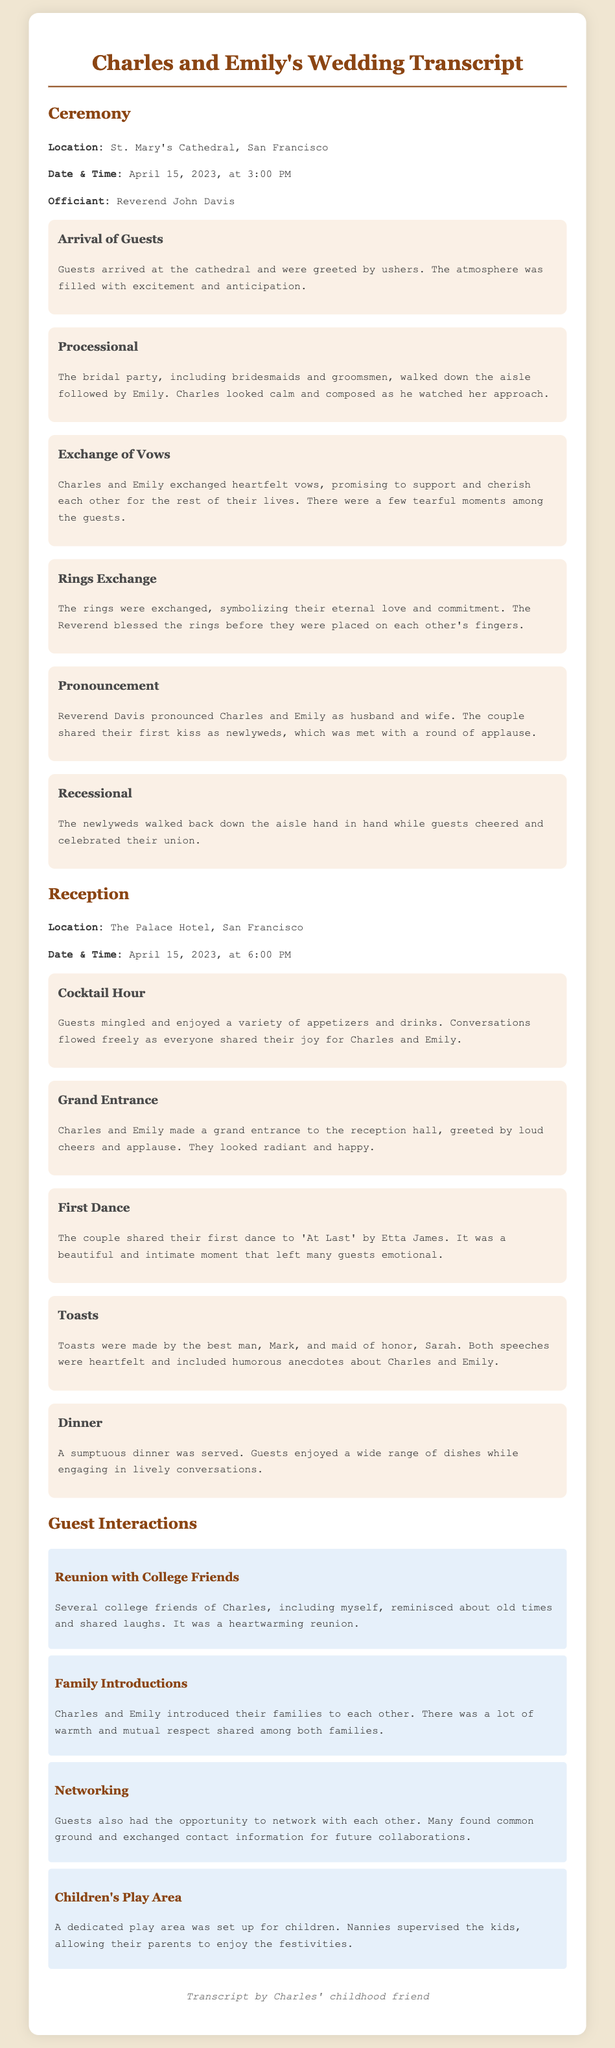what was the ceremony location? The ceremony took place at St. Mary's Cathedral in San Francisco as mentioned in the document.
Answer: St. Mary's Cathedral, San Francisco who officiated the wedding? The officiant of the wedding ceremony was Reverend John Davis as stated in the transcript.
Answer: Reverend John Davis what song did Charles and Emily dance to for their first dance? The document states that they shared their first dance to 'At Last' by Etta James.
Answer: 'At Last' by Etta James who made the toasts at the reception? According to the transcript, the toasts were made by the best man, Mark, and maid of honor, Sarah.
Answer: Mark and Sarah how many guests engaged in networking at the reception? The document does not specify an exact number, but states that guests had the opportunity to network with each other.
Answer: Not specified what time did the reception start? The timeline in the document indicates that the reception started at 6:00 PM.
Answer: 6:00 PM what type of area was set up for children? The document mentions that a dedicated play area was established for children during the reception.
Answer: Children's play area how did guests react when Charles and Emily were pronounced husband and wife? The document reveals that guests responded with a round of applause when the couple was pronounced husband and wife.
Answer: Round of applause 